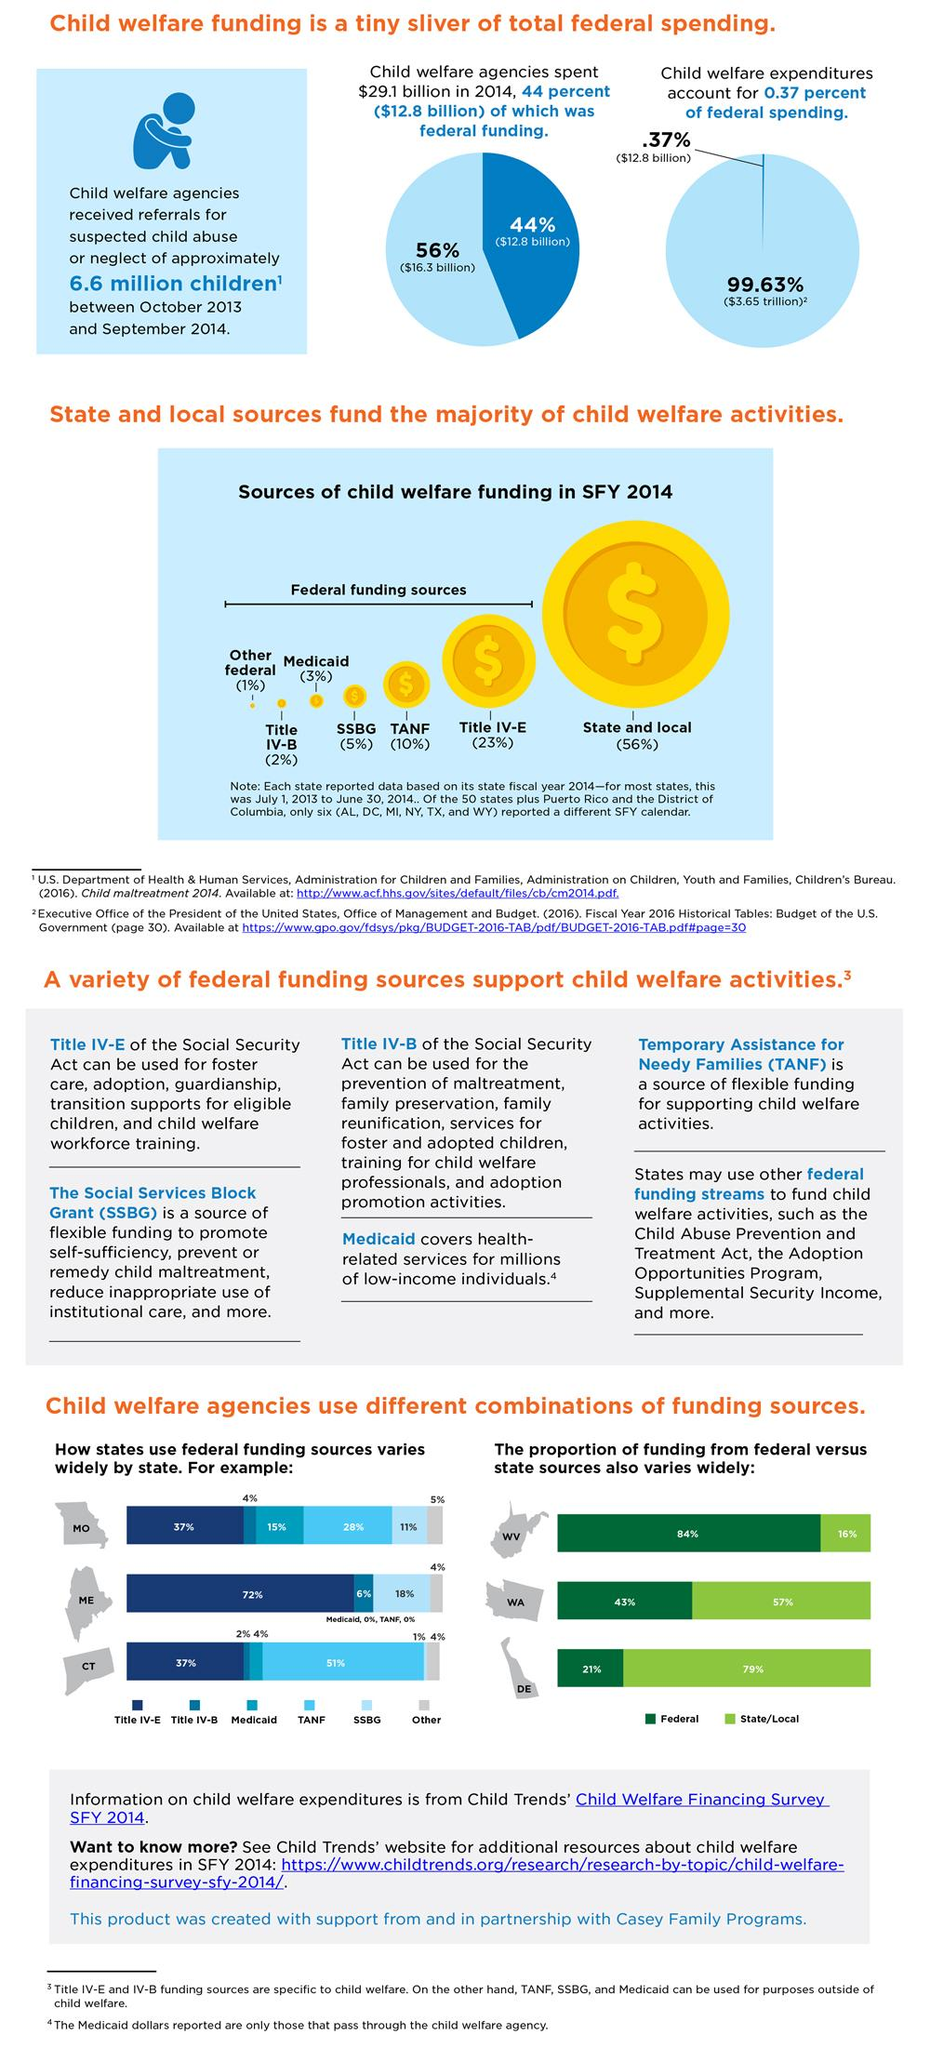Draw attention to some important aspects in this diagram. In 2014, the Title IV-E program of the federal government provided the largest amount of funding for child welfare services. Maine primarily utilizes Title IV-E funding as its primary source of federal funding for child welfare services. The most commonly used funding source for child welfare in West Virginia is federal funding. The contribution of Medicaid was minimal, as it only accounted for 3%. In 2014, the total amount of federal expenditures, excluding expenditures related to child welfare, was $3.65 trillion. 